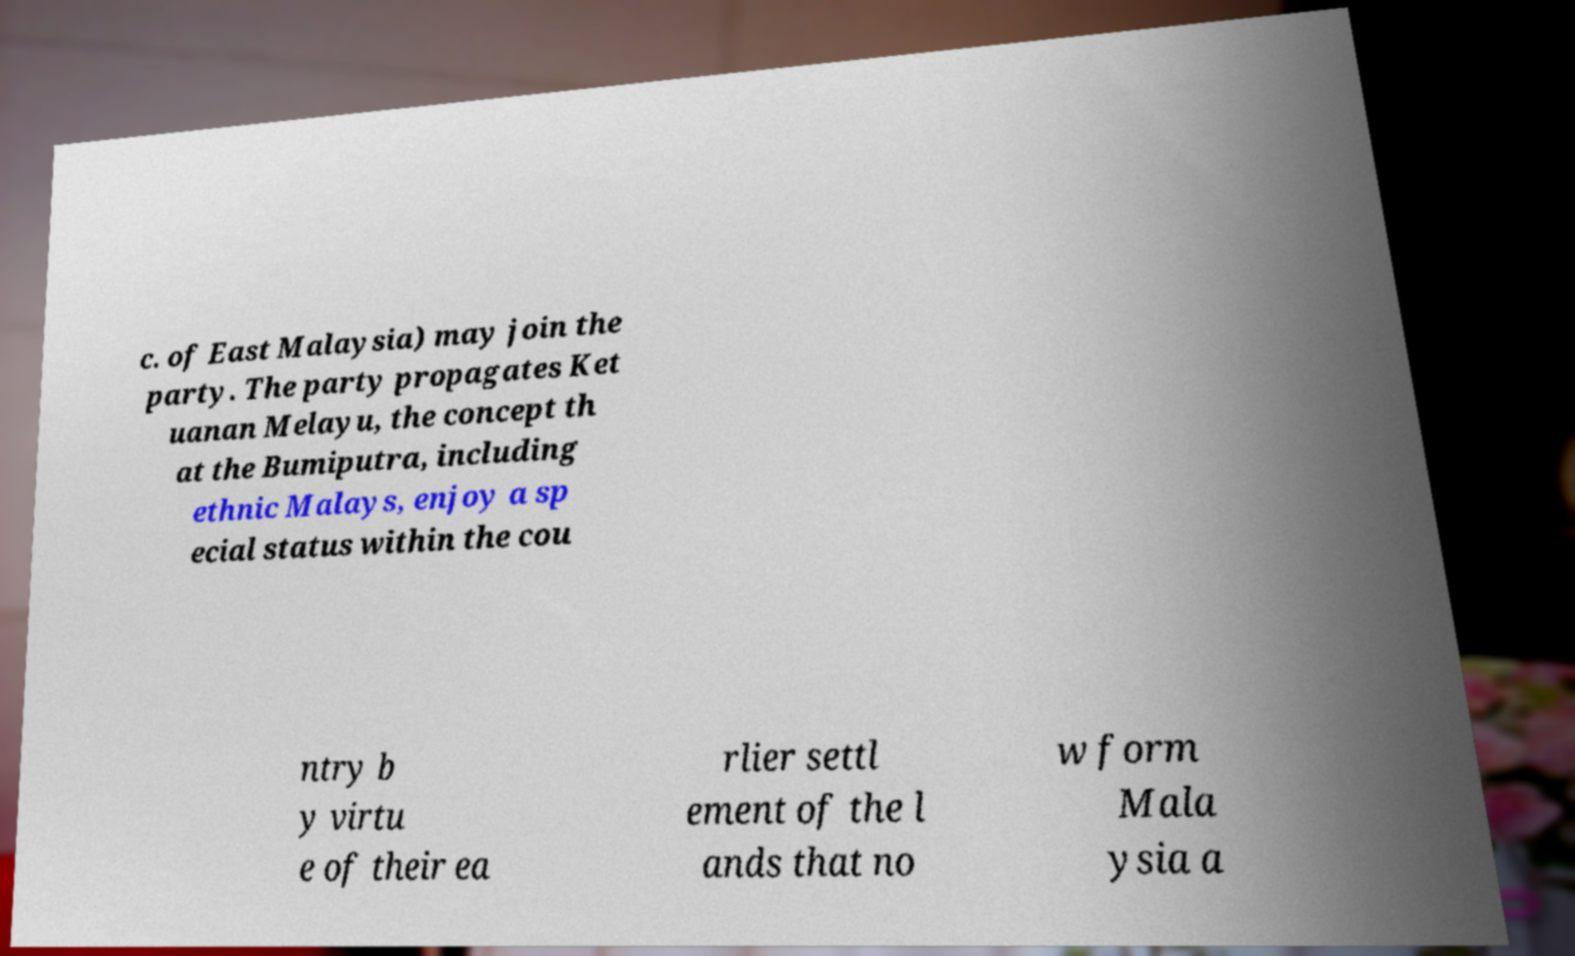Please read and relay the text visible in this image. What does it say? c. of East Malaysia) may join the party. The party propagates Ket uanan Melayu, the concept th at the Bumiputra, including ethnic Malays, enjoy a sp ecial status within the cou ntry b y virtu e of their ea rlier settl ement of the l ands that no w form Mala ysia a 